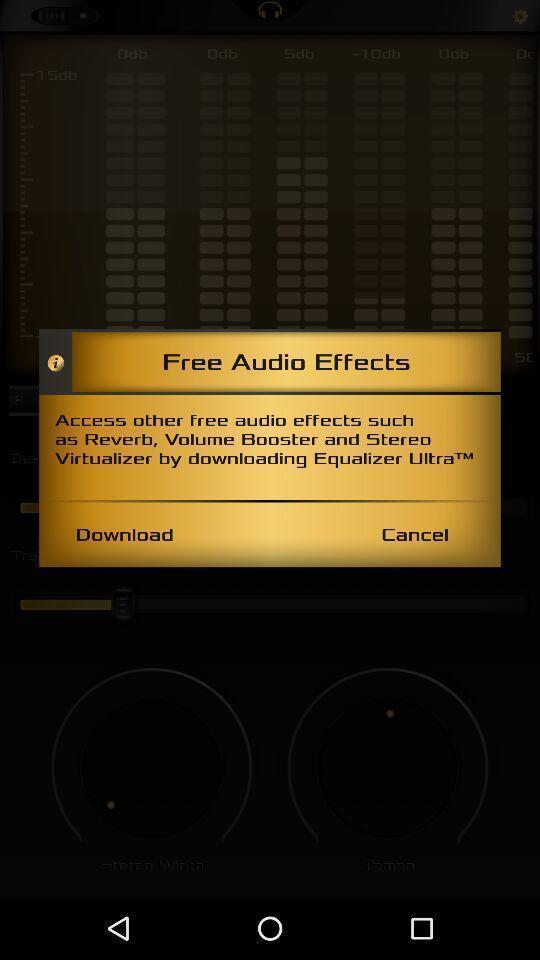Give me a narrative description of this picture. Popup to download in the music app. 